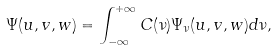<formula> <loc_0><loc_0><loc_500><loc_500>\Psi ( u , v , w ) = \int _ { - \infty } ^ { + \infty } C ( \nu ) \Psi _ { \nu } ( u , v , w ) d \nu ,</formula> 